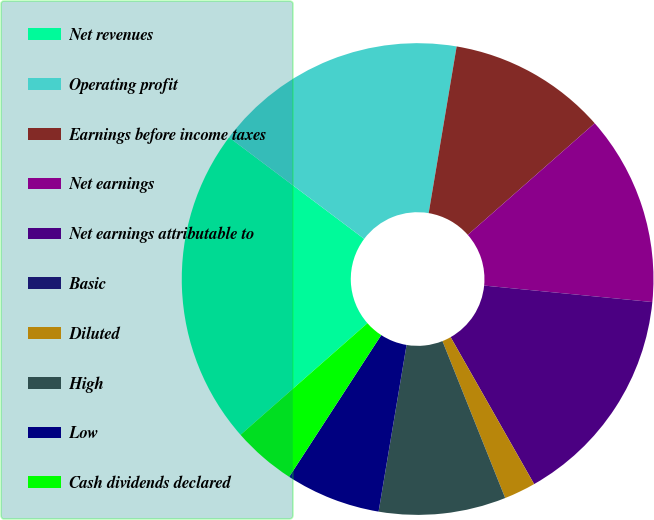Convert chart. <chart><loc_0><loc_0><loc_500><loc_500><pie_chart><fcel>Net revenues<fcel>Operating profit<fcel>Earnings before income taxes<fcel>Net earnings<fcel>Net earnings attributable to<fcel>Basic<fcel>Diluted<fcel>High<fcel>Low<fcel>Cash dividends declared<nl><fcel>21.74%<fcel>17.39%<fcel>10.87%<fcel>13.04%<fcel>15.22%<fcel>0.0%<fcel>2.17%<fcel>8.7%<fcel>6.52%<fcel>4.35%<nl></chart> 